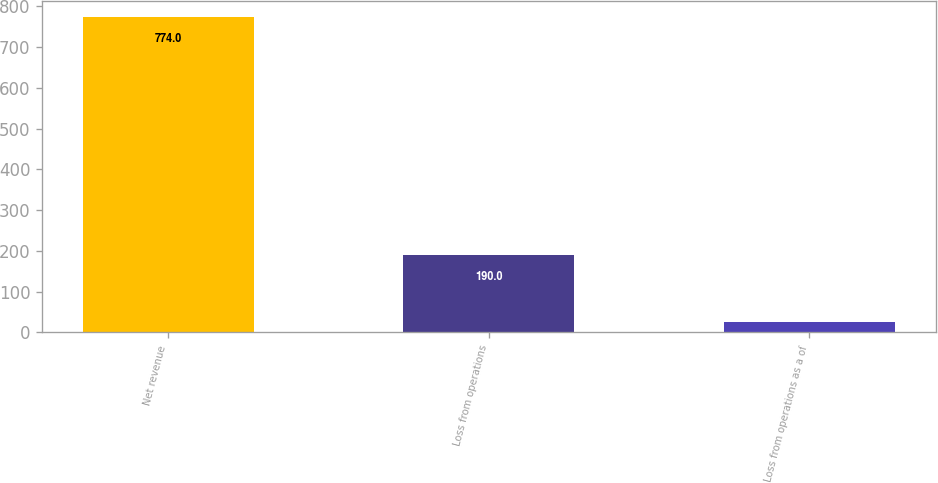Convert chart. <chart><loc_0><loc_0><loc_500><loc_500><bar_chart><fcel>Net revenue<fcel>Loss from operations<fcel>Loss from operations as a of<nl><fcel>774<fcel>190<fcel>24.5<nl></chart> 